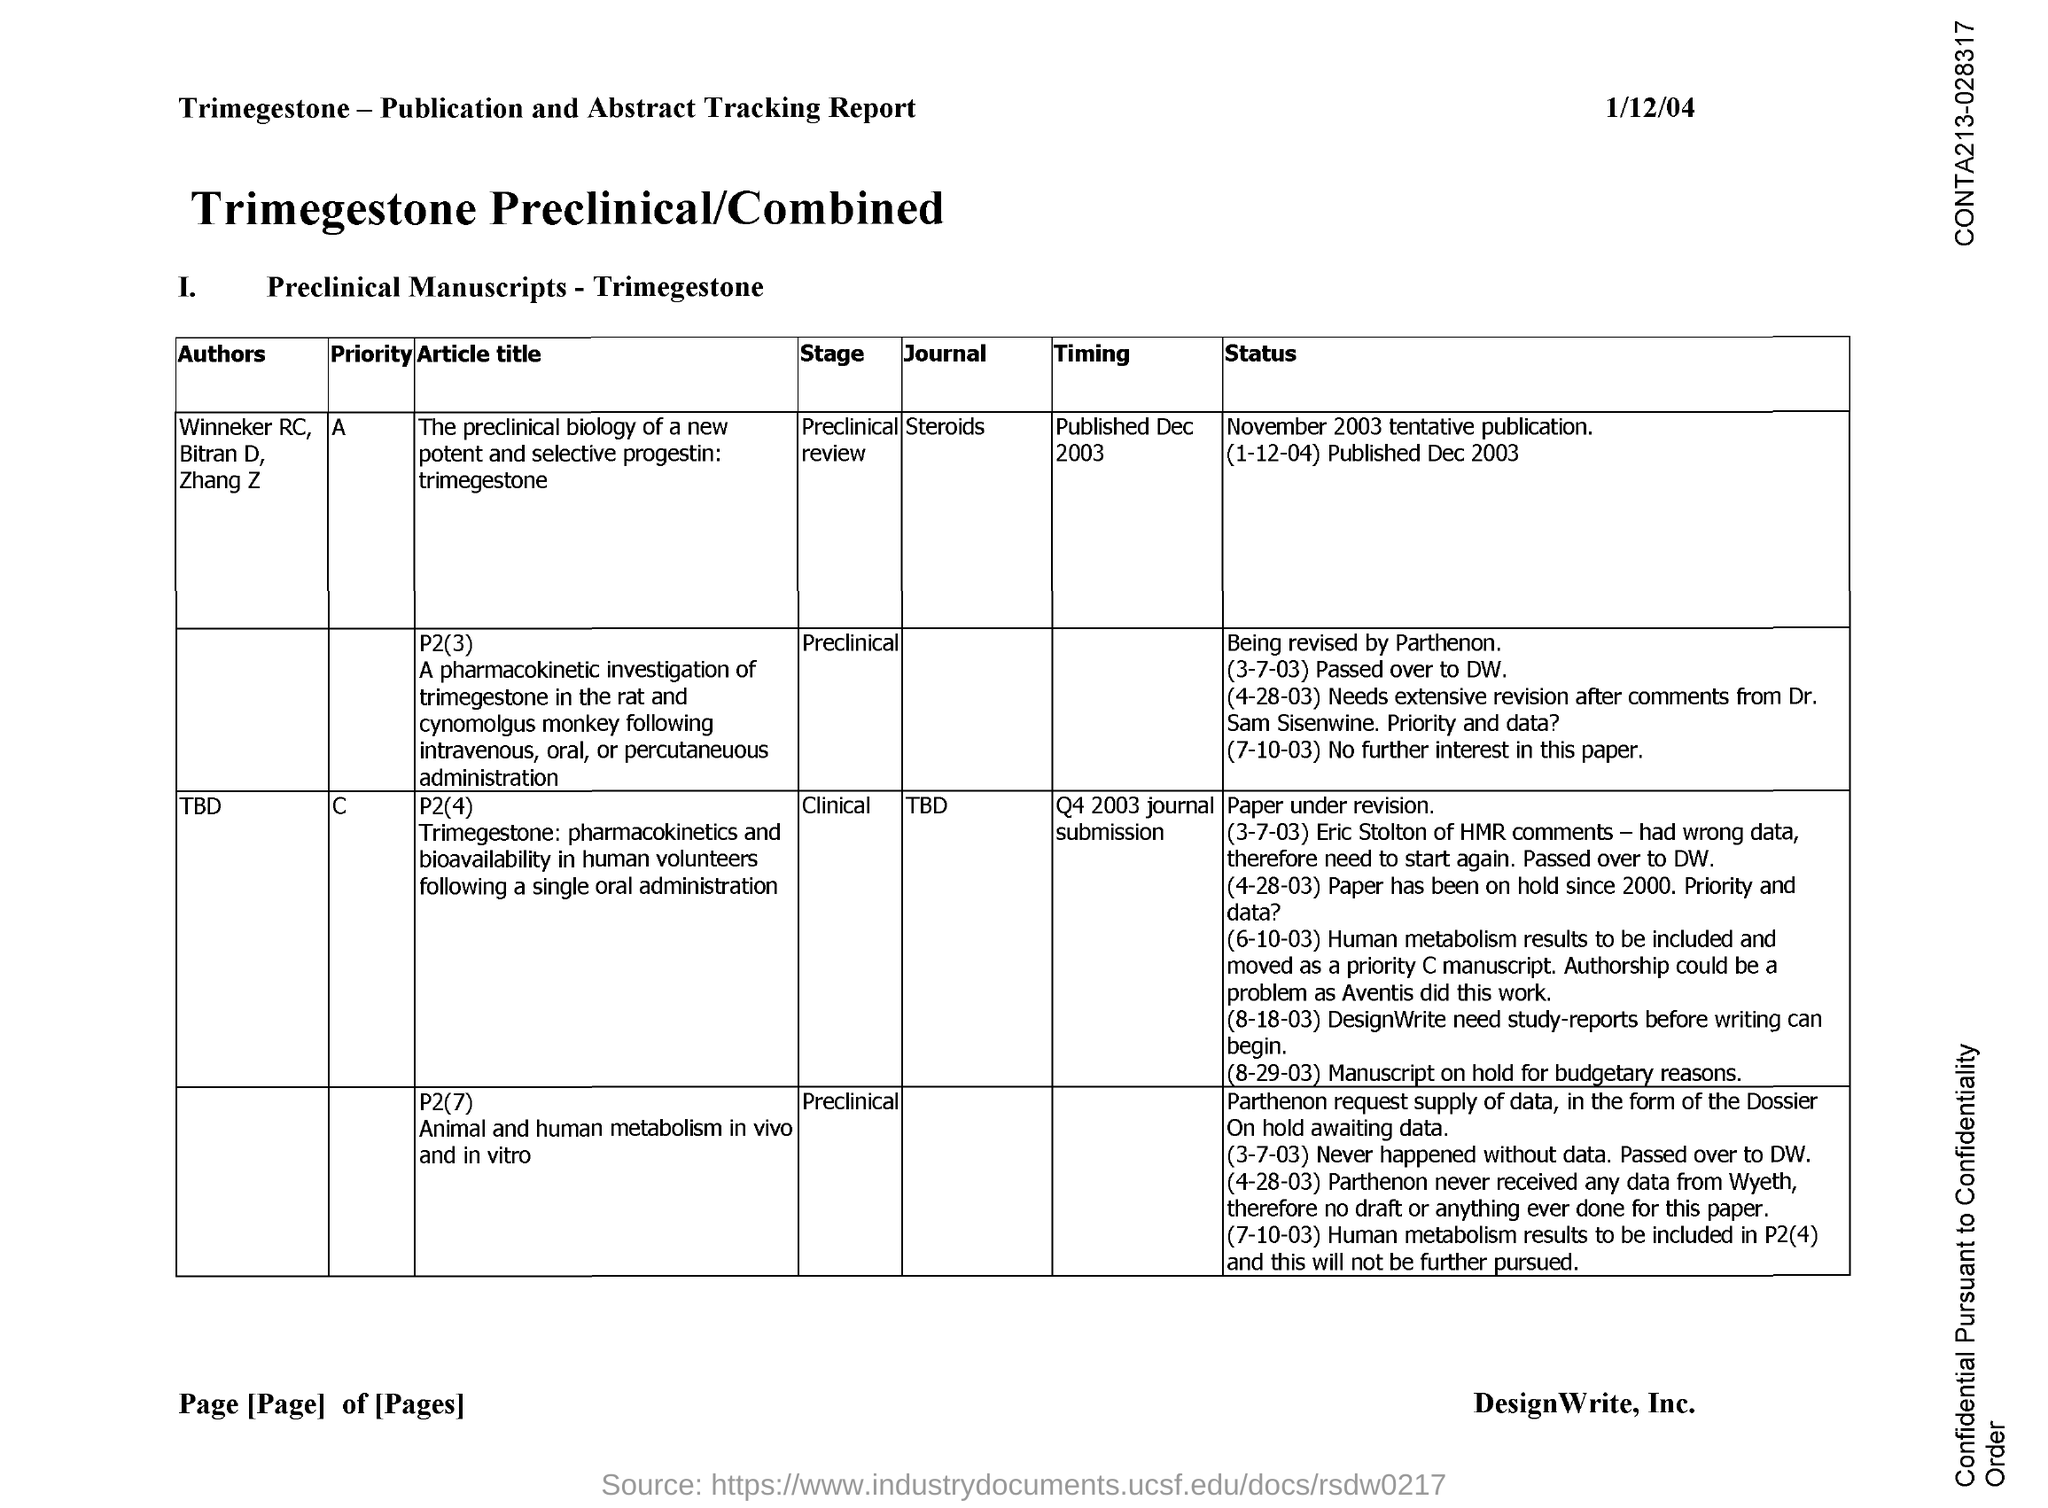What is the date on the document?
Make the answer very short. 1/12/04. What is the timing for journal "Steroids"?
Your answer should be very brief. Published Dec 2003. 